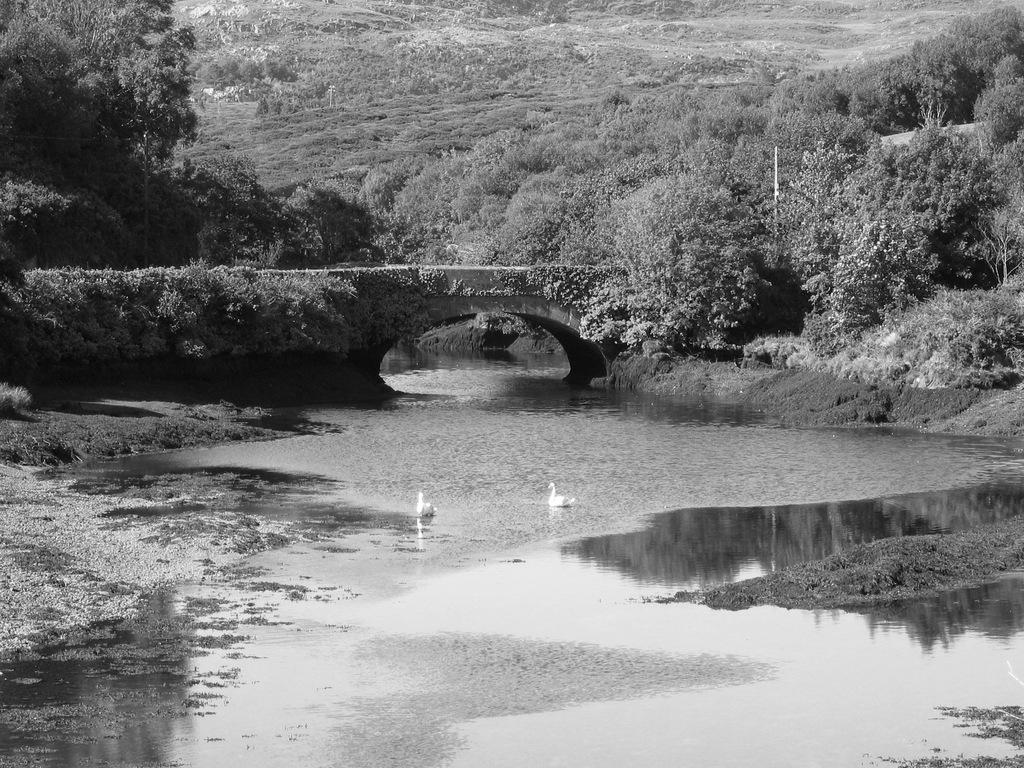How many birds can be seen in the image? There are two birds in the image. Where are the birds located? The birds are on the water in the image. What other structures or objects are present in the image? There is a bridge in the image. What type of vegetation can be seen in the background of the image? There are plants and trees in the background of the image. How many zebras are flying over the bridge in the image? There are no zebras present in the image, and no planes or clouds are mentioned, so it is not possible to answer this question. 